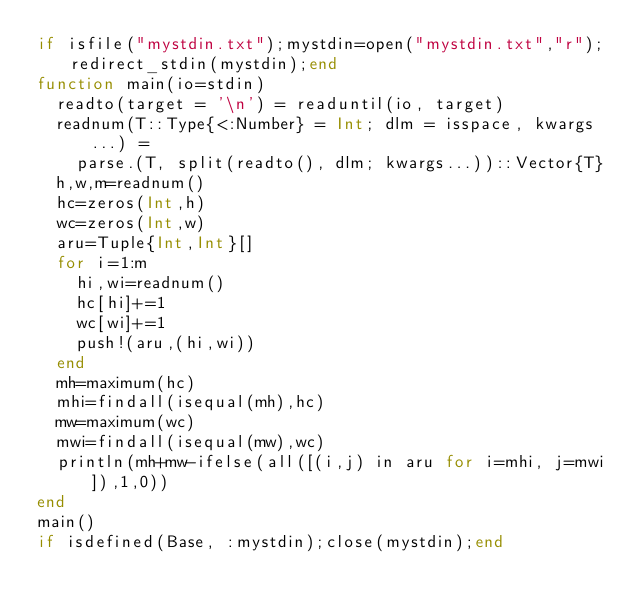<code> <loc_0><loc_0><loc_500><loc_500><_Julia_>if isfile("mystdin.txt");mystdin=open("mystdin.txt","r");redirect_stdin(mystdin);end
function main(io=stdin)
  readto(target = '\n') = readuntil(io, target)
  readnum(T::Type{<:Number} = Int; dlm = isspace, kwargs...) =
    parse.(T, split(readto(), dlm; kwargs...))::Vector{T}
  h,w,m=readnum()
  hc=zeros(Int,h)
  wc=zeros(Int,w)
  aru=Tuple{Int,Int}[]
  for i=1:m
    hi,wi=readnum()
    hc[hi]+=1
    wc[wi]+=1
    push!(aru,(hi,wi))
  end
  mh=maximum(hc)
  mhi=findall(isequal(mh),hc)
  mw=maximum(wc)
  mwi=findall(isequal(mw),wc)
  println(mh+mw-ifelse(all([(i,j) in aru for i=mhi, j=mwi]),1,0))
end
main()
if isdefined(Base, :mystdin);close(mystdin);end</code> 